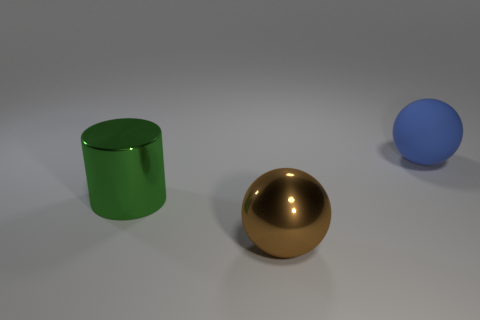Add 2 big shiny objects. How many objects exist? 5 Subtract all brown spheres. How many spheres are left? 1 Add 2 large green metal cylinders. How many large green metal cylinders exist? 3 Subtract 0 purple blocks. How many objects are left? 3 Subtract all spheres. How many objects are left? 1 Subtract 1 balls. How many balls are left? 1 Subtract all gray spheres. Subtract all red cylinders. How many spheres are left? 2 Subtract all yellow spheres. How many purple cylinders are left? 0 Subtract all big shiny cylinders. Subtract all large blue things. How many objects are left? 1 Add 2 big green metal cylinders. How many big green metal cylinders are left? 3 